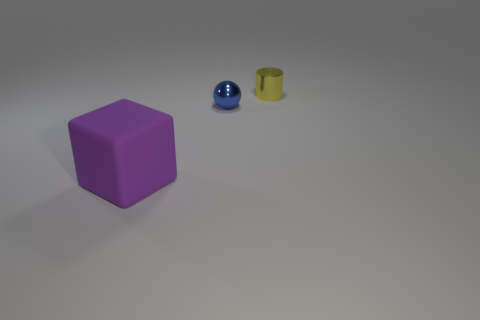Is there anything else that has the same size as the purple cube?
Keep it short and to the point. No. Does the thing in front of the blue thing have the same material as the tiny object that is in front of the tiny yellow cylinder?
Your response must be concise. No. How many objects have the same color as the big block?
Offer a terse response. 0. What shape is the small object that is to the left of the tiny yellow thing that is behind the shiny sphere?
Make the answer very short. Sphere. How many blue things have the same material as the tiny yellow cylinder?
Give a very brief answer. 1. What is the small thing behind the tiny shiny sphere made of?
Keep it short and to the point. Metal. What shape is the tiny object to the right of the shiny thing that is in front of the small metal object that is on the right side of the blue metal sphere?
Ensure brevity in your answer.  Cylinder. There is a object that is in front of the sphere; does it have the same color as the tiny shiny thing in front of the cylinder?
Give a very brief answer. No. Are there fewer large cubes that are right of the blue metal thing than large objects on the right side of the purple object?
Your answer should be compact. No. Are there any other things that are the same shape as the blue object?
Your answer should be compact. No. 